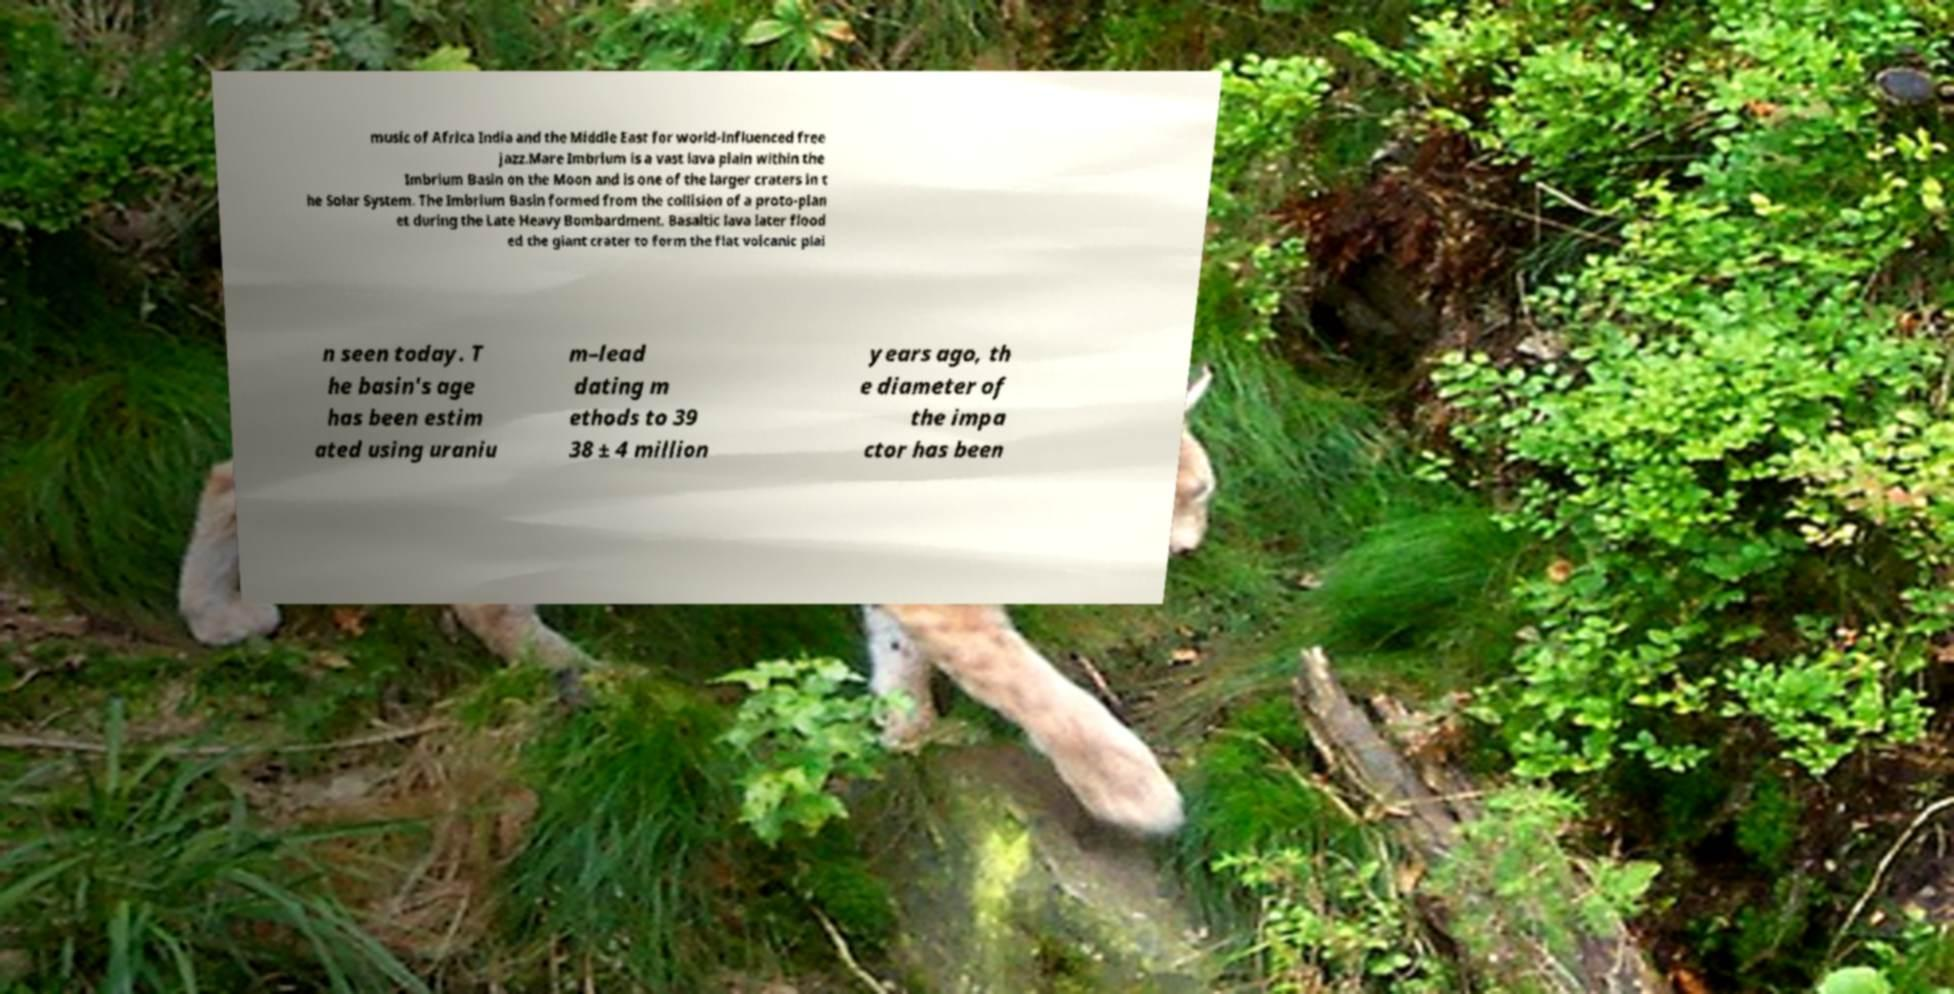I need the written content from this picture converted into text. Can you do that? music of Africa India and the Middle East for world-influenced free jazz.Mare Imbrium is a vast lava plain within the Imbrium Basin on the Moon and is one of the larger craters in t he Solar System. The Imbrium Basin formed from the collision of a proto-plan et during the Late Heavy Bombardment. Basaltic lava later flood ed the giant crater to form the flat volcanic plai n seen today. T he basin's age has been estim ated using uraniu m–lead dating m ethods to 39 38 ± 4 million years ago, th e diameter of the impa ctor has been 